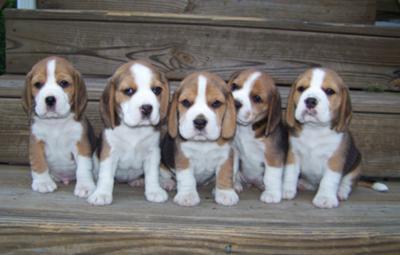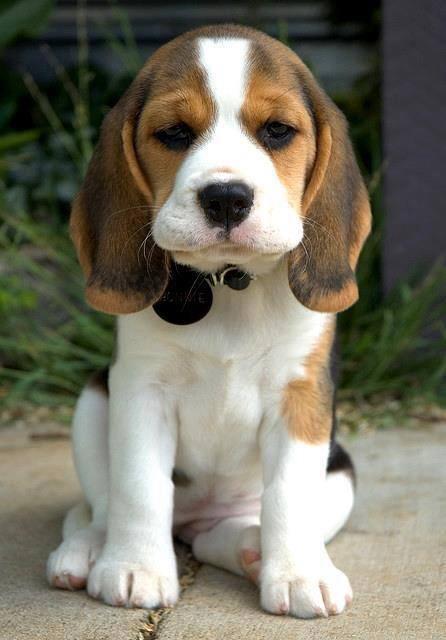The first image is the image on the left, the second image is the image on the right. Examine the images to the left and right. Is the description "One of the images has exactly two dogs." accurate? Answer yes or no. No. The first image is the image on the left, the second image is the image on the right. Evaluate the accuracy of this statement regarding the images: "There are at most five dogs.". Is it true? Answer yes or no. No. 